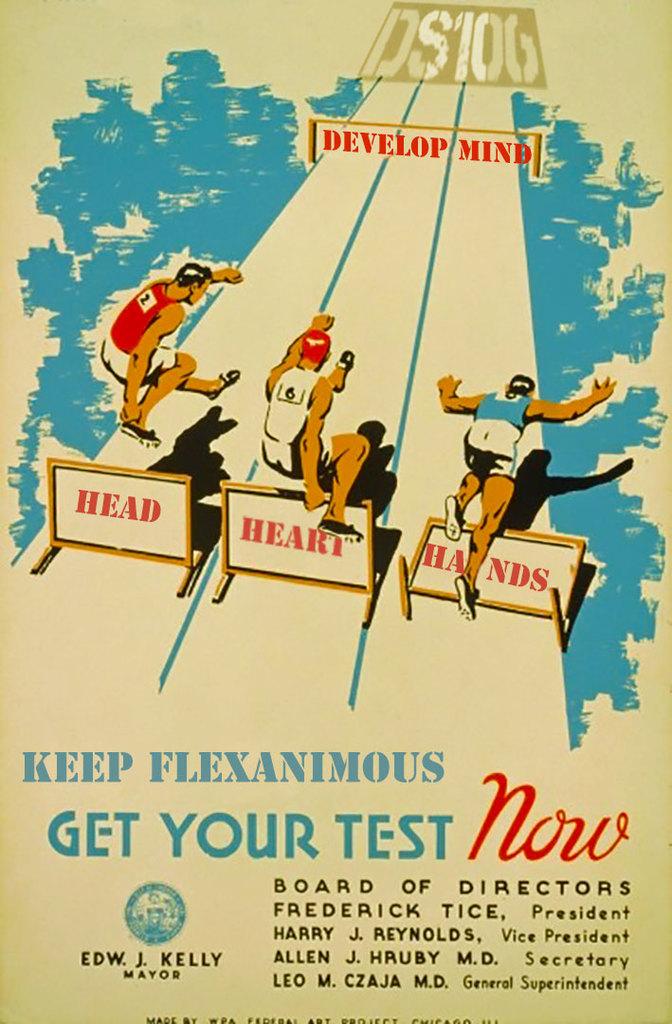Who is the president?
Offer a very short reply. Frederick tice. 